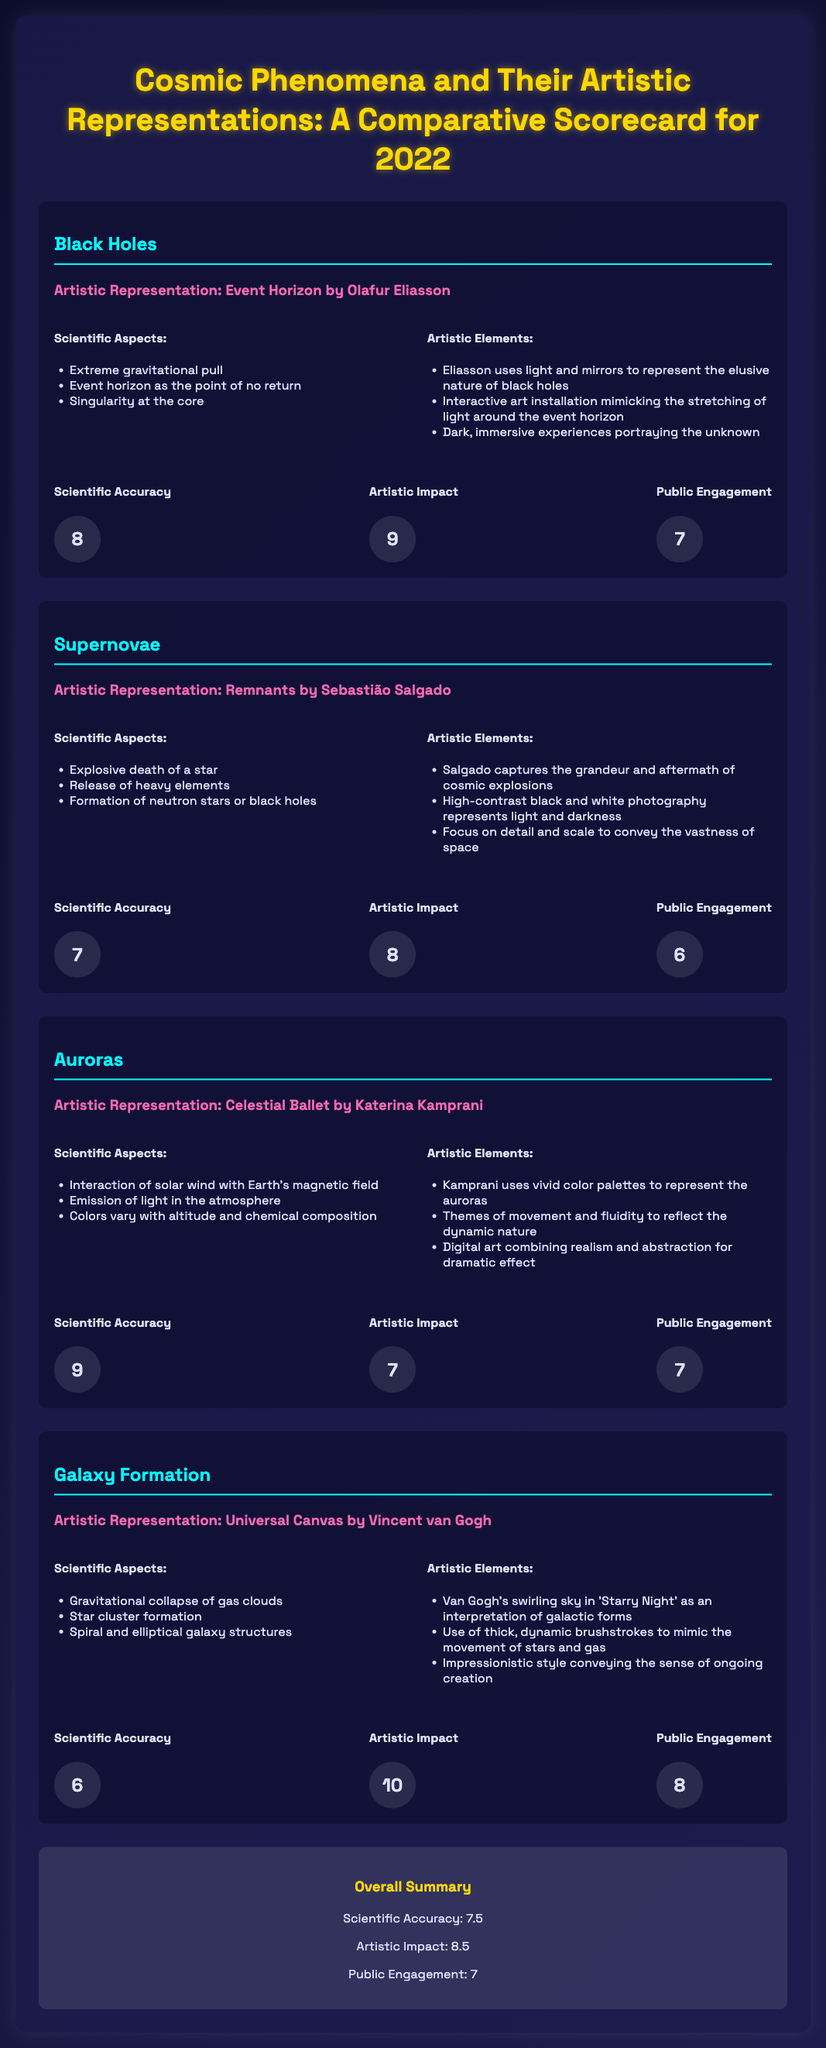What is the artistic representation of black holes? The document states that the artistic representation of black holes is "Event Horizon by Olafur Eliasson."
Answer: Event Horizon by Olafur Eliasson What score did black holes receive for scientific accuracy? The scorecard lists the scientific accuracy score for black holes as 8.
Answer: 8 Which cosmic phenomenon has the highest artistic impact score? By comparing the scores, it is clear that "Galaxy Formation" has the highest artistic impact score of 10.
Answer: 10 What are the scientific aspects of auroras? The scientific aspects of auroras listed in the document include interaction of solar wind with Earth's magnetic field, emission of light in the atmosphere, and colors vary with altitude and chemical composition.
Answer: Interaction of solar wind with Earth's magnetic field, emission of light in the atmosphere, colors vary with altitude and chemical composition What is the public engagement score for supernovae? According to the document, the public engagement score for supernovae is 6.
Answer: 6 Which artist created "Celestial Ballet"? The document identifies Katerina Kamprani as the creator of "Celestial Ballet."
Answer: Katerina Kamprani What is the overall average scientific accuracy score for the phenomena listed? The overall average scientific accuracy score is calculated to be 7.5.
Answer: 7.5 What artistic element does Eliasson use in his representation of black holes? Eliasson uses light and mirrors to represent the elusive nature of black holes.
Answer: Light and mirrors 